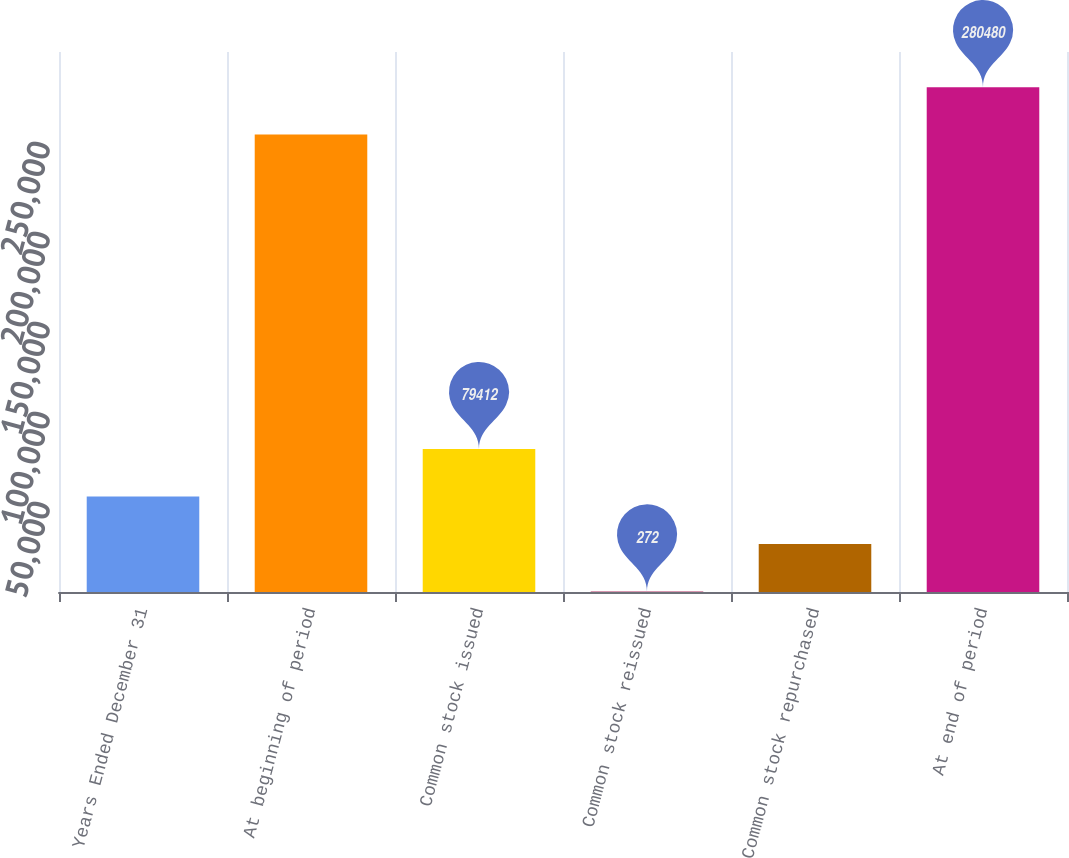Convert chart to OTSL. <chart><loc_0><loc_0><loc_500><loc_500><bar_chart><fcel>Years Ended December 31<fcel>At beginning of period<fcel>Common stock issued<fcel>Common stock reissued<fcel>Common stock repurchased<fcel>At end of period<nl><fcel>53032<fcel>254100<fcel>79412<fcel>272<fcel>26652<fcel>280480<nl></chart> 